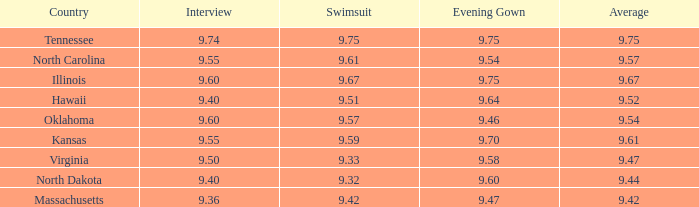What was the average for the country with the swimsuit score of 9.57? 9.54. 